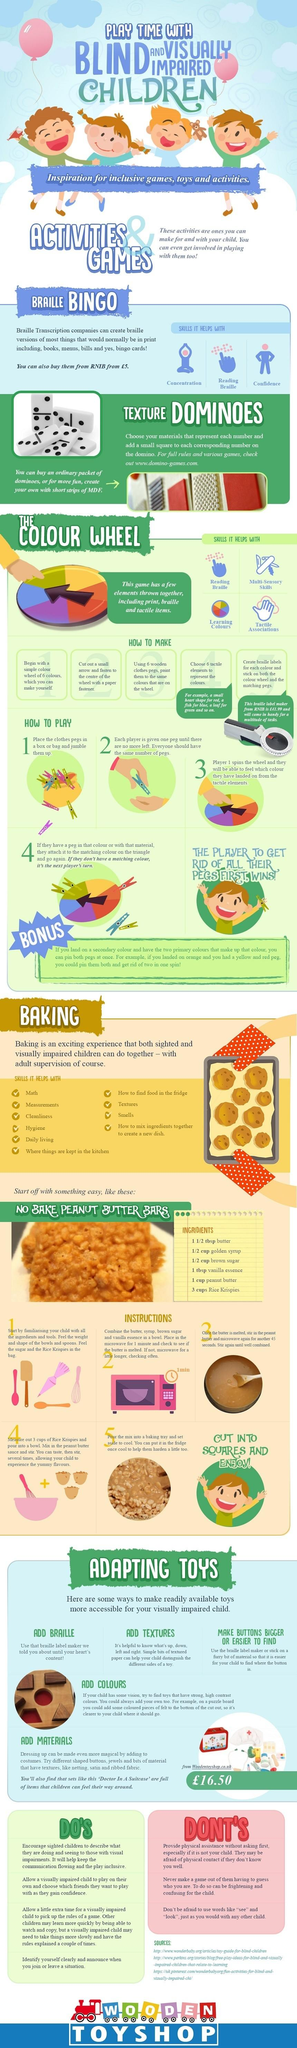Indicate a few pertinent items in this graphic. There are three listed sources. Braille Bingo offers three key benefits: improved concentration, enhanced reading skills in Braille, and increased confidence. 